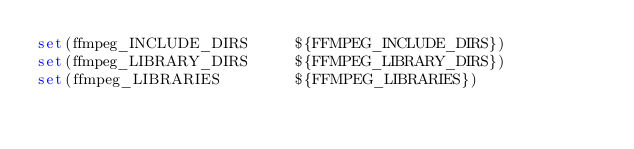Convert code to text. <code><loc_0><loc_0><loc_500><loc_500><_CMake_>set(ffmpeg_INCLUDE_DIRS   	${FFMPEG_INCLUDE_DIRS})
set(ffmpeg_LIBRARY_DIRS   	${FFMPEG_LIBRARY_DIRS})
set(ffmpeg_LIBRARIES 	      ${FFMPEG_LIBRARIES})
</code> 